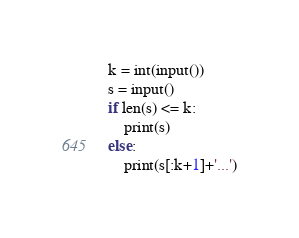<code> <loc_0><loc_0><loc_500><loc_500><_Python_>k = int(input())
s = input()
if len(s) <= k:
    print(s)
else:
    print(s[:k+1]+'...')</code> 